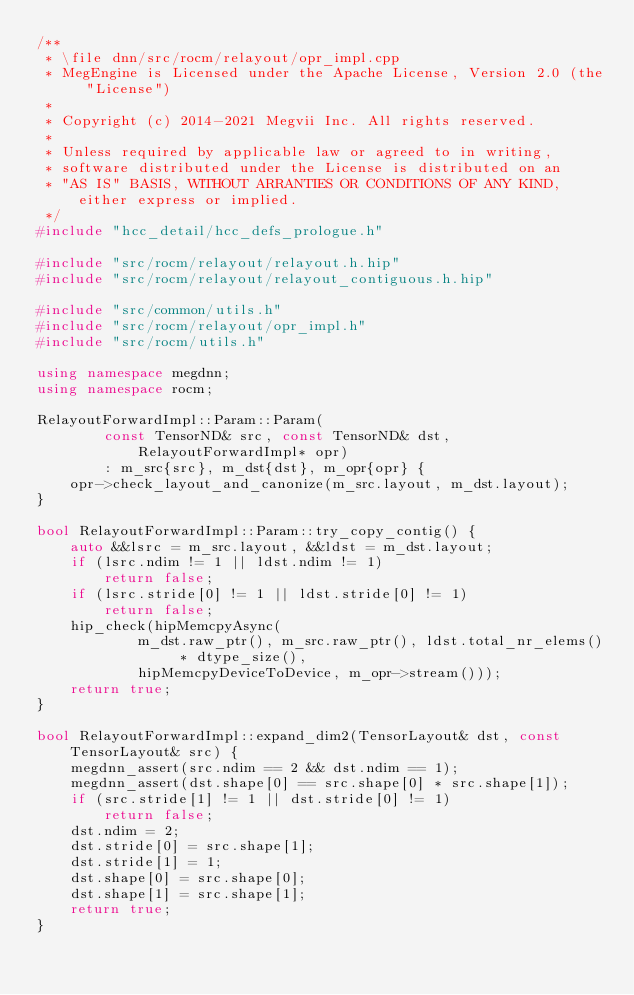<code> <loc_0><loc_0><loc_500><loc_500><_C++_>/**
 * \file dnn/src/rocm/relayout/opr_impl.cpp
 * MegEngine is Licensed under the Apache License, Version 2.0 (the "License")
 *
 * Copyright (c) 2014-2021 Megvii Inc. All rights reserved.
 *
 * Unless required by applicable law or agreed to in writing,
 * software distributed under the License is distributed on an
 * "AS IS" BASIS, WITHOUT ARRANTIES OR CONDITIONS OF ANY KIND, either express or implied.
 */
#include "hcc_detail/hcc_defs_prologue.h"

#include "src/rocm/relayout/relayout.h.hip"
#include "src/rocm/relayout/relayout_contiguous.h.hip"

#include "src/common/utils.h"
#include "src/rocm/relayout/opr_impl.h"
#include "src/rocm/utils.h"

using namespace megdnn;
using namespace rocm;

RelayoutForwardImpl::Param::Param(
        const TensorND& src, const TensorND& dst, RelayoutForwardImpl* opr)
        : m_src{src}, m_dst{dst}, m_opr{opr} {
    opr->check_layout_and_canonize(m_src.layout, m_dst.layout);
}

bool RelayoutForwardImpl::Param::try_copy_contig() {
    auto &&lsrc = m_src.layout, &&ldst = m_dst.layout;
    if (lsrc.ndim != 1 || ldst.ndim != 1)
        return false;
    if (lsrc.stride[0] != 1 || ldst.stride[0] != 1)
        return false;
    hip_check(hipMemcpyAsync(
            m_dst.raw_ptr(), m_src.raw_ptr(), ldst.total_nr_elems() * dtype_size(),
            hipMemcpyDeviceToDevice, m_opr->stream()));
    return true;
}

bool RelayoutForwardImpl::expand_dim2(TensorLayout& dst, const TensorLayout& src) {
    megdnn_assert(src.ndim == 2 && dst.ndim == 1);
    megdnn_assert(dst.shape[0] == src.shape[0] * src.shape[1]);
    if (src.stride[1] != 1 || dst.stride[0] != 1)
        return false;
    dst.ndim = 2;
    dst.stride[0] = src.shape[1];
    dst.stride[1] = 1;
    dst.shape[0] = src.shape[0];
    dst.shape[1] = src.shape[1];
    return true;
}
</code> 